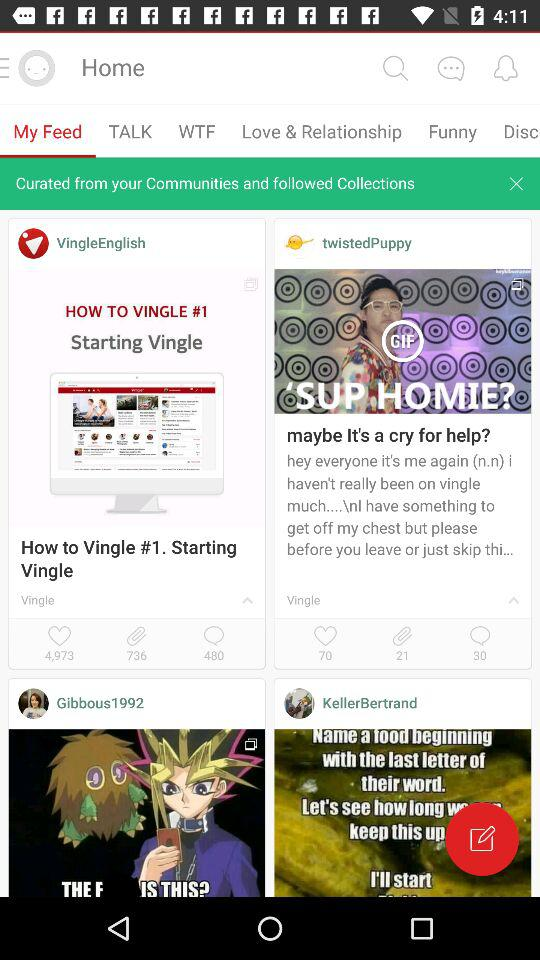How many comments are there in "VingleEnglish"? There are 480 comments in "VingleEnglish". 